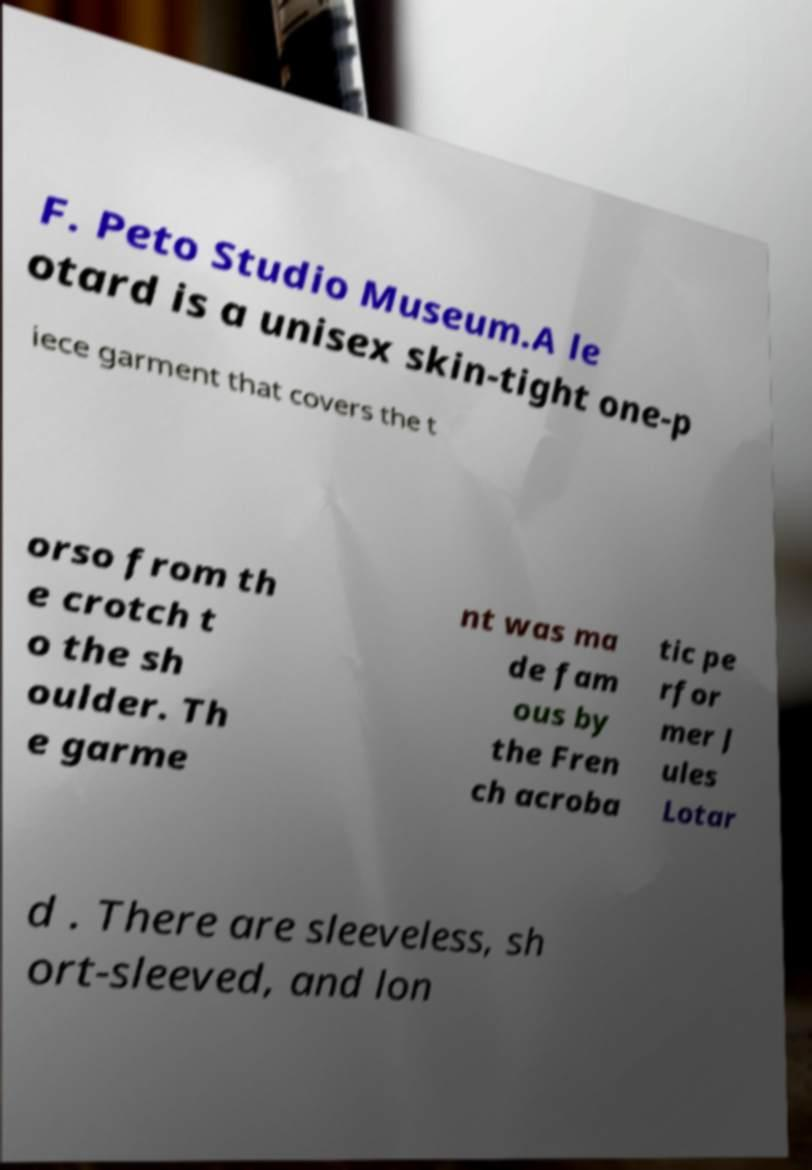For documentation purposes, I need the text within this image transcribed. Could you provide that? F. Peto Studio Museum.A le otard is a unisex skin-tight one-p iece garment that covers the t orso from th e crotch t o the sh oulder. Th e garme nt was ma de fam ous by the Fren ch acroba tic pe rfor mer J ules Lotar d . There are sleeveless, sh ort-sleeved, and lon 